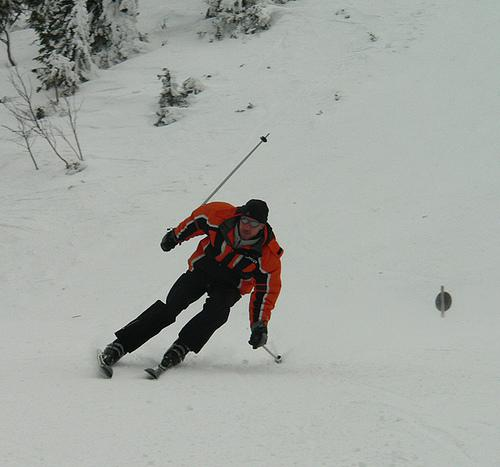Question: what is the man holding?
Choices:
A. Skiis.
B. Helmet.
C. Poles.
D. Gear.
Answer with the letter. Answer: C Question: where is the man's hat?
Choices:
A. Hands.
B. Table.
C. Head.
D. Rack.
Answer with the letter. Answer: C Question: why is the man skiing?
Choices:
A. Competition.
B. Vacation.
C. Recreation.
D. Work.
Answer with the letter. Answer: C Question: what color is the man pants?
Choices:
A. Blue.
B. Tan.
C. White.
D. Black.
Answer with the letter. Answer: D Question: who is wearing a coat?
Choices:
A. The man.
B. The skier.
C. The woman.
D. The child.
Answer with the letter. Answer: B 